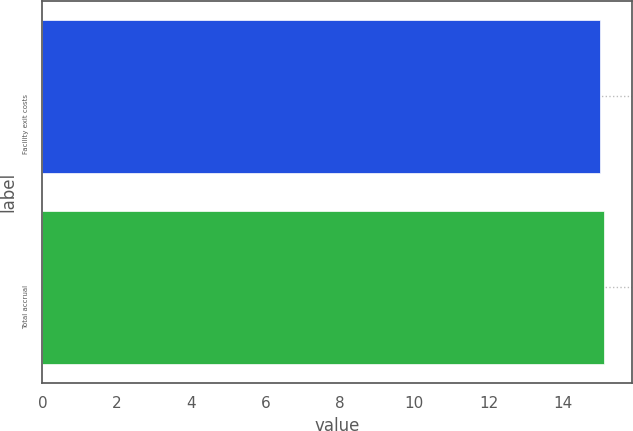Convert chart. <chart><loc_0><loc_0><loc_500><loc_500><bar_chart><fcel>Facility exit costs<fcel>Total accrual<nl><fcel>15<fcel>15.1<nl></chart> 